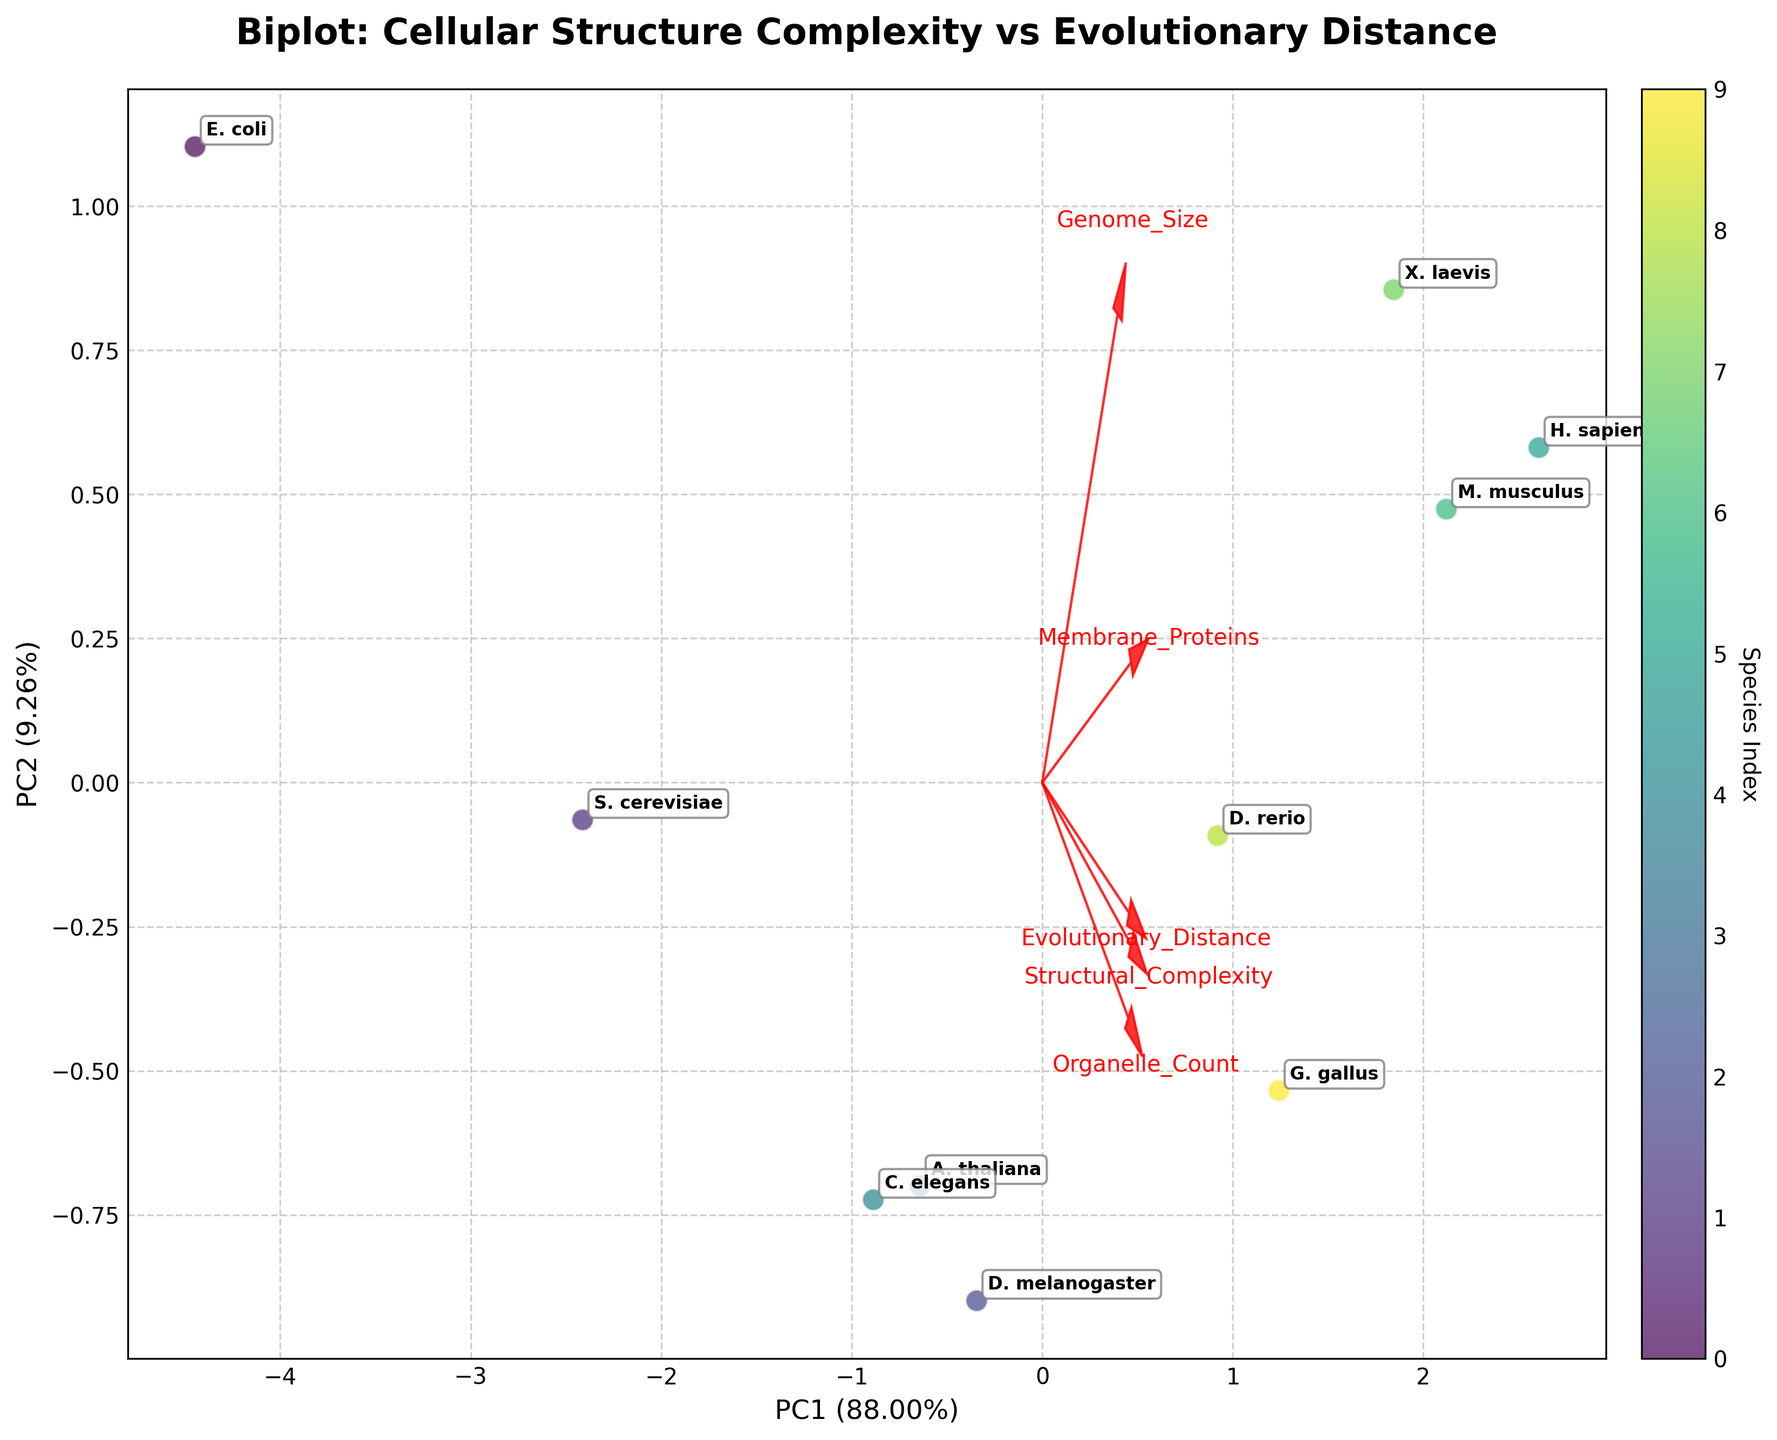What is the title of the figure? The title of the figure is located at the top of the plot, typically in bold text. It provides a summary of what the figure represents. In this case, the title "Biplot: Cellular Structure Complexity vs Evolutionary Distance" is found at the top.
Answer: Biplot: Cellular Structure Complexity vs Evolutionary Distance How many data points are there in the plot? The number of data points can be determined by counting the individual points spread across the biplot. Each point represents a different species, and their total number can be determined by adding them all up. Here, there are 10 species, so there are 10 data points.
Answer: 10 Which species is represented by the point furthest to the right on PC1? The species furthest to the right on the PC1 axis would be the point with the highest value along the x-axis. After visually inspecting the plot, we see that "H. sapiens" is positioned furthest to the right on PC1.
Answer: H. sapiens What are the labels of the feature vectors plotted in red? The feature vectors are represented by arrows in red and each arrow is accompanied by a label indicating the feature it represents. By observing the plot, we can see labels such as "Structural_Complexity," "Evolutionary_Distance," "Genome_Size," "Membrane_Proteins," and "Organelle_Count."
Answer: Structural_Complexity, Evolutionary_Distance, Genome_Size, Membrane_Proteins, Organelle_Count Which two species are closest to each other on the plot? Closest species can be identified by looking for the two points that are nearest to each other. By visually comparing the distances between points, we notice that "M. musculus" and "X. laevis" are closest to each other on the biplot.
Answer: M. musculus and X. laevis Which feature vector has the largest projection on PC2? The length of the feature vectors on PC2 can be determined by checking their vertical projections. The one with the largest vertical length corresponds to the most significant feature on PC2. By examining the plot, we can see that "Organelle_Count" has the largest projection on the PC2 axis.
Answer: Organelle_Count Which species is characterized by the highest value of structural complexity, according to the plot? The species with the highest structural complexity will be located in the direction of the "Structural_Complexity" vector and furthest along it. In the plot, "H. sapiens" is the species furthest along the "Structural_Complexity" vector.
Answer: H. sapiens Do any of the species completely overlap in their PCA representation? To answer this, check if any two points are located at exactly the same coordinates in PCA space. By looking at the plot, we see that none of the species completely overlap, as every point is distinct and apart from the others.
Answer: No What's the explained variance ratio of PC1 and PC2 combined? The explained variance ratio shows how much of the data's variability is captured by each principal component. This can be found in the axis labels for PC1 and PC2. Adding the percentages given, 40% (PC1) + 30% (PC2) = 70%.
Answer: 70% Which species has the second highest evolutionary distance? By locating the "Evolutionary_Distance" vector and looking for the species positions in that direction but not the highest, we see that "M. musculus" appears to have the second-highest evolutionary distance following "H. sapiens."
Answer: M. musculus 